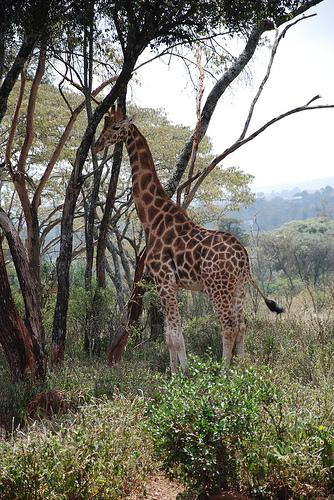Express a poetic observation about the scene depicted in the image. Amidst nature's serene embrace, a giraffe gazes curiously, enveloped in the shadows of the leafy enclave. Give a concise summary of the various objects found on the ground in the image. Brown dirt, leafy bushes, and broken tree stumps cover the ground. Describe leaves and branches appearance in the image. There are leafy green trees, leafless tree branches, and a bush with many leaves in the image. Write a detailed sentence that highlights the unique aspects of the main subject. The giraffe has a brown pattern, black markings in the spots, white legs, and horns on its head with a tail having a black tuft at the end. List three prominent features of the backdrop in the image. Hazy sky, mountain range, trees with broken bark. In an informal manner, briefly describe the main subject. Oh, look! A tall giraffe with funky spots is chillin' under some trees. Mention the main characteristics of the sky in this image. The sky is clear, hazy, with different shades of blue. Explain the environment which the main subject of the image is located in. The giraffe is standing in the shade of trees amidst lush green bushes, broken tree stumps, and patches of dirt. Convey the visual information about the vegetation in the image. Leafy green trees, lush green bushes, and broken-down tree stumps surround the giraffe. Provide a short and simple statement about the picture's primary subject. A giraffe is standing under trees and looking at the camera. 